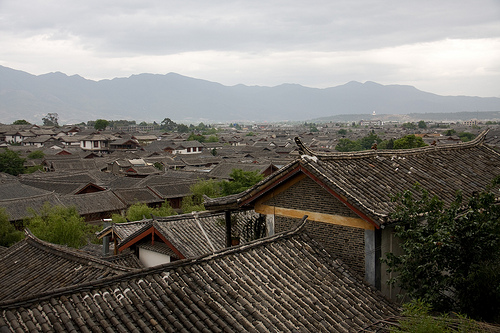<image>
Is there a roof under the roof? No. The roof is not positioned under the roof. The vertical relationship between these objects is different. 